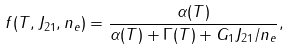Convert formula to latex. <formula><loc_0><loc_0><loc_500><loc_500>f ( T , J _ { 2 1 } , n _ { e } ) = \frac { \alpha ( T ) } { \alpha ( T ) + \Gamma ( T ) + G _ { 1 } J _ { 2 1 } / n _ { e } } ,</formula> 